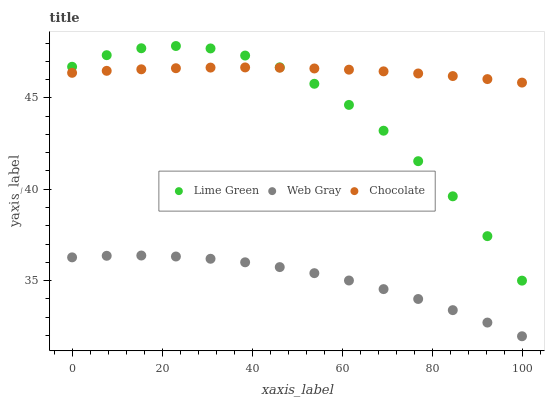Does Web Gray have the minimum area under the curve?
Answer yes or no. Yes. Does Chocolate have the maximum area under the curve?
Answer yes or no. Yes. Does Lime Green have the minimum area under the curve?
Answer yes or no. No. Does Lime Green have the maximum area under the curve?
Answer yes or no. No. Is Chocolate the smoothest?
Answer yes or no. Yes. Is Lime Green the roughest?
Answer yes or no. Yes. Is Lime Green the smoothest?
Answer yes or no. No. Is Chocolate the roughest?
Answer yes or no. No. Does Web Gray have the lowest value?
Answer yes or no. Yes. Does Lime Green have the lowest value?
Answer yes or no. No. Does Lime Green have the highest value?
Answer yes or no. Yes. Does Chocolate have the highest value?
Answer yes or no. No. Is Web Gray less than Lime Green?
Answer yes or no. Yes. Is Lime Green greater than Web Gray?
Answer yes or no. Yes. Does Chocolate intersect Lime Green?
Answer yes or no. Yes. Is Chocolate less than Lime Green?
Answer yes or no. No. Is Chocolate greater than Lime Green?
Answer yes or no. No. Does Web Gray intersect Lime Green?
Answer yes or no. No. 